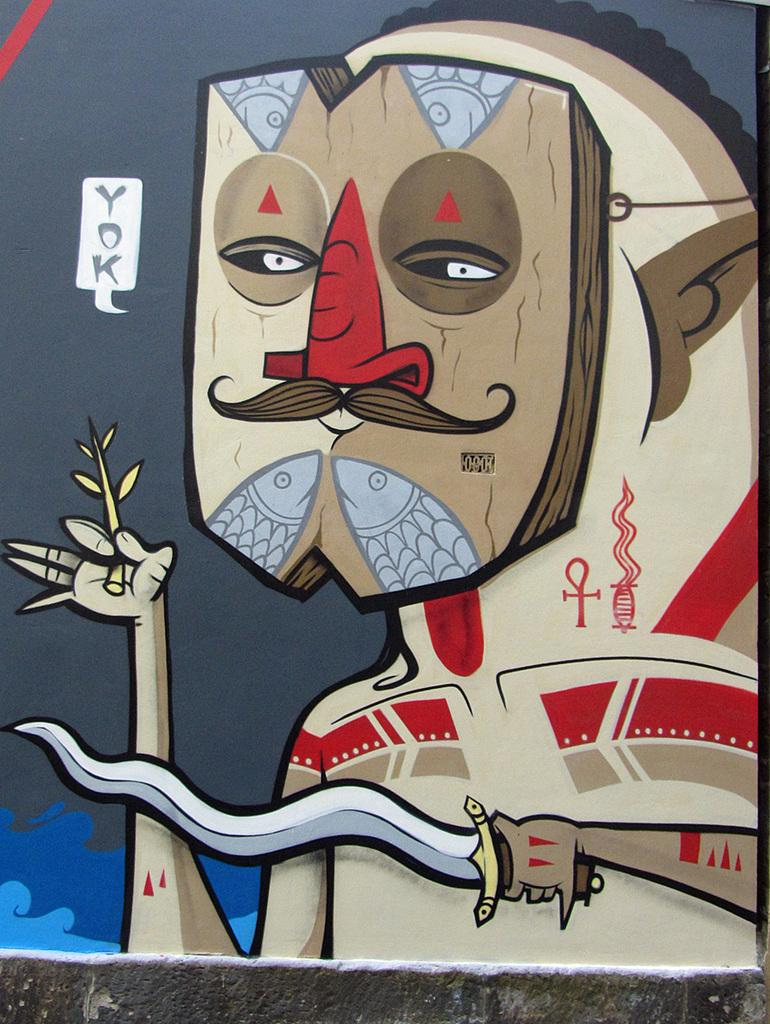What type of object is made of wood in the image? There is a wooden object in the image. What is depicted on the wooden object? The wooden object has a face drawn on it. What is the wooden object holding in one of its hands? The wooden object has a knife in one of its hands. What is the wooden object holding in its other hand? The wooden object has an object in another hand. What type of coil can be seen in the middle of the wooden object's face? There is no coil present in the image, nor is there any mention of a coil in the provided facts. 